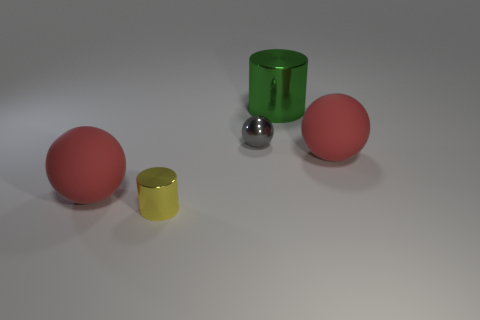Add 1 cyan rubber cubes. How many objects exist? 6 Subtract all rubber balls. How many balls are left? 1 Subtract all green cylinders. How many cylinders are left? 1 Subtract all cylinders. How many objects are left? 3 Subtract all yellow blocks. How many gray balls are left? 1 Add 1 big blue cylinders. How many big blue cylinders exist? 1 Subtract 0 gray blocks. How many objects are left? 5 Subtract all brown spheres. Subtract all green cylinders. How many spheres are left? 3 Subtract all gray objects. Subtract all tiny green matte spheres. How many objects are left? 4 Add 5 large rubber spheres. How many large rubber spheres are left? 7 